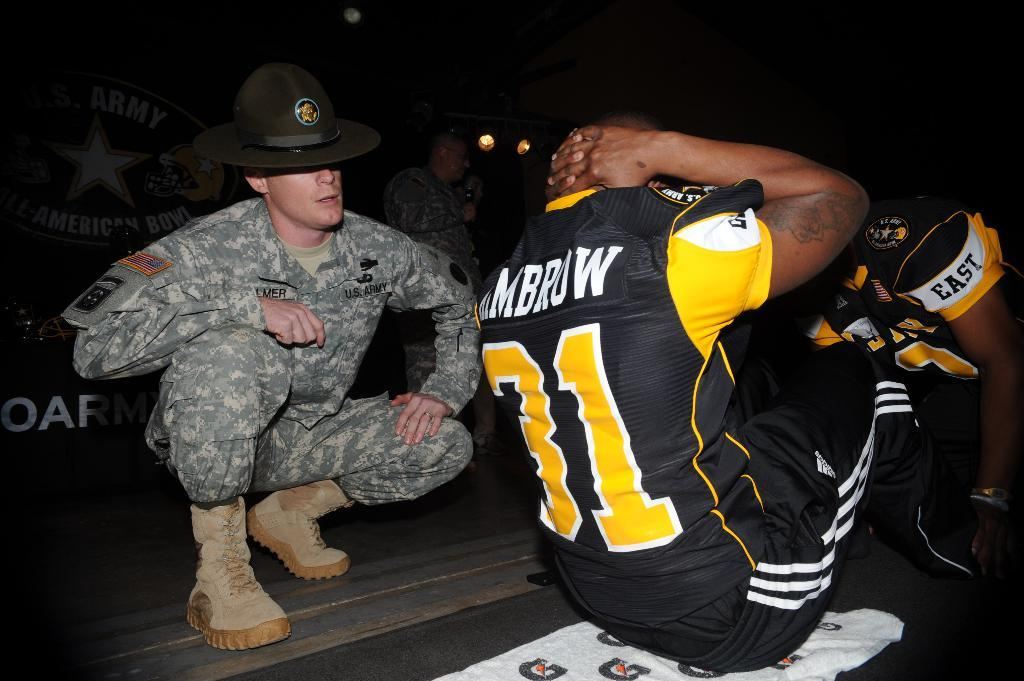<image>
Relay a brief, clear account of the picture shown. an army guy is by a football guy number 31 doing sit ups 